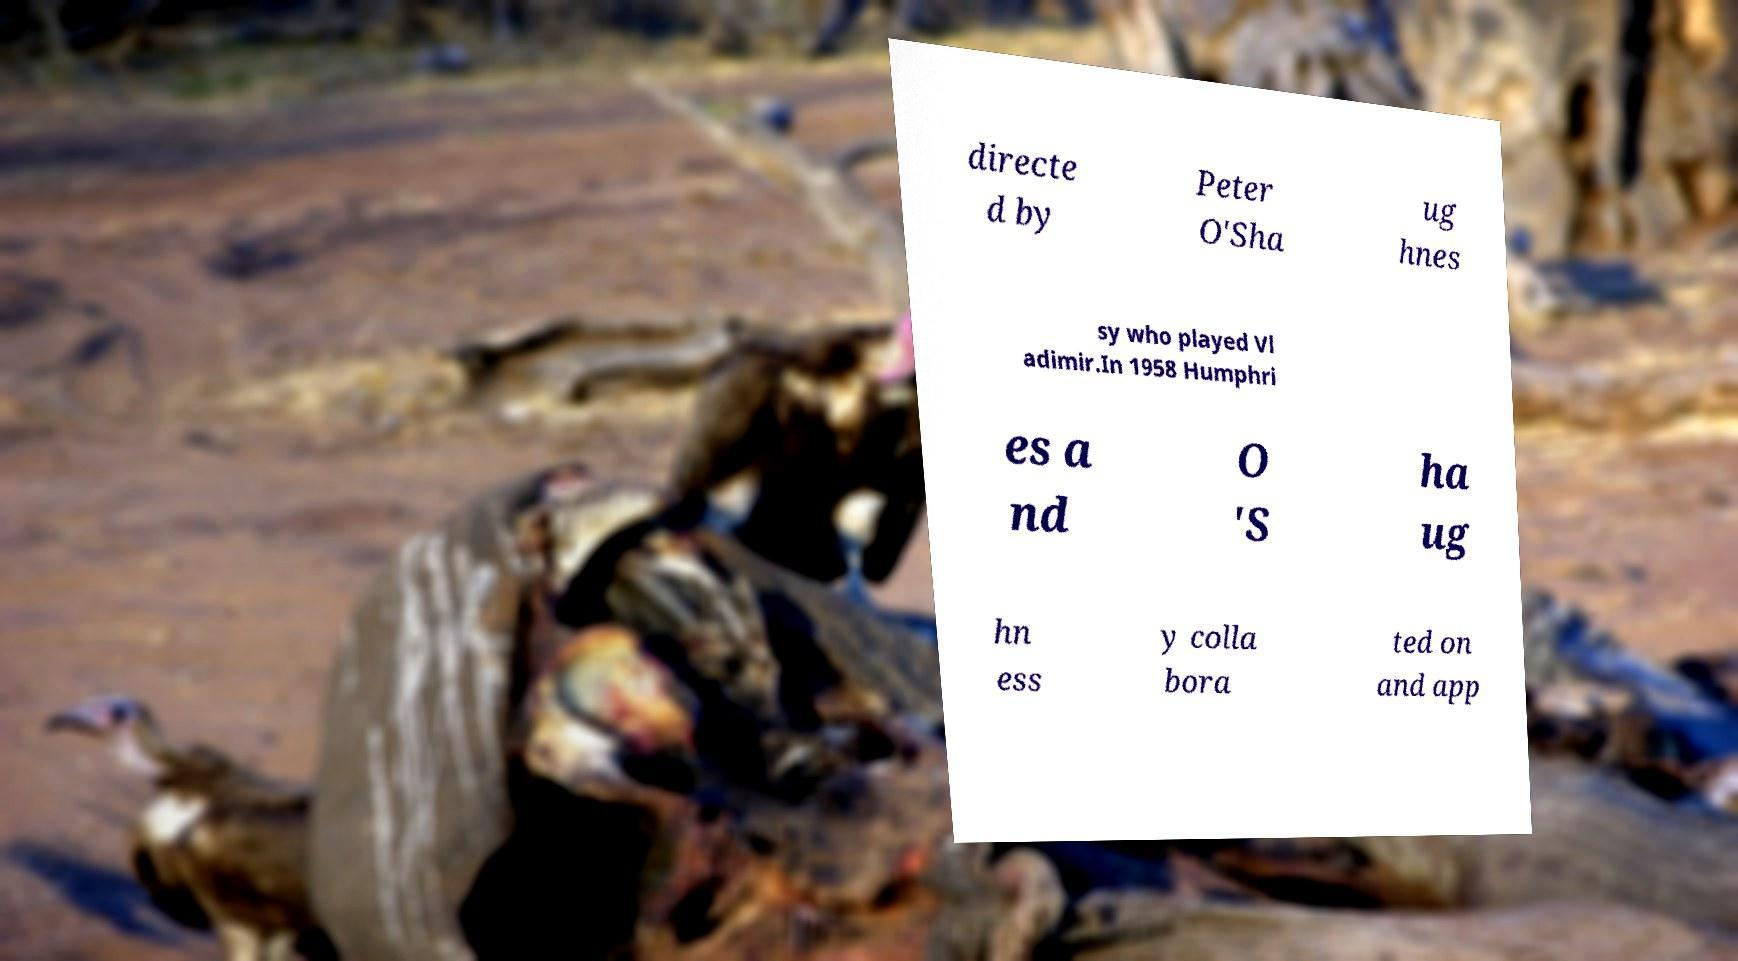Could you assist in decoding the text presented in this image and type it out clearly? directe d by Peter O'Sha ug hnes sy who played Vl adimir.In 1958 Humphri es a nd O 'S ha ug hn ess y colla bora ted on and app 